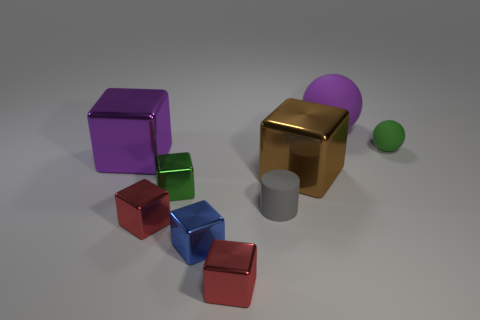Subtract all small green cubes. How many cubes are left? 5 Subtract all green balls. How many red blocks are left? 2 Subtract all brown cubes. How many cubes are left? 5 Subtract all gray blocks. Subtract all brown spheres. How many blocks are left? 6 Subtract all cylinders. How many objects are left? 8 Add 5 green objects. How many green objects are left? 7 Add 4 tiny gray matte cylinders. How many tiny gray matte cylinders exist? 5 Subtract 0 green cylinders. How many objects are left? 9 Subtract all purple things. Subtract all cubes. How many objects are left? 1 